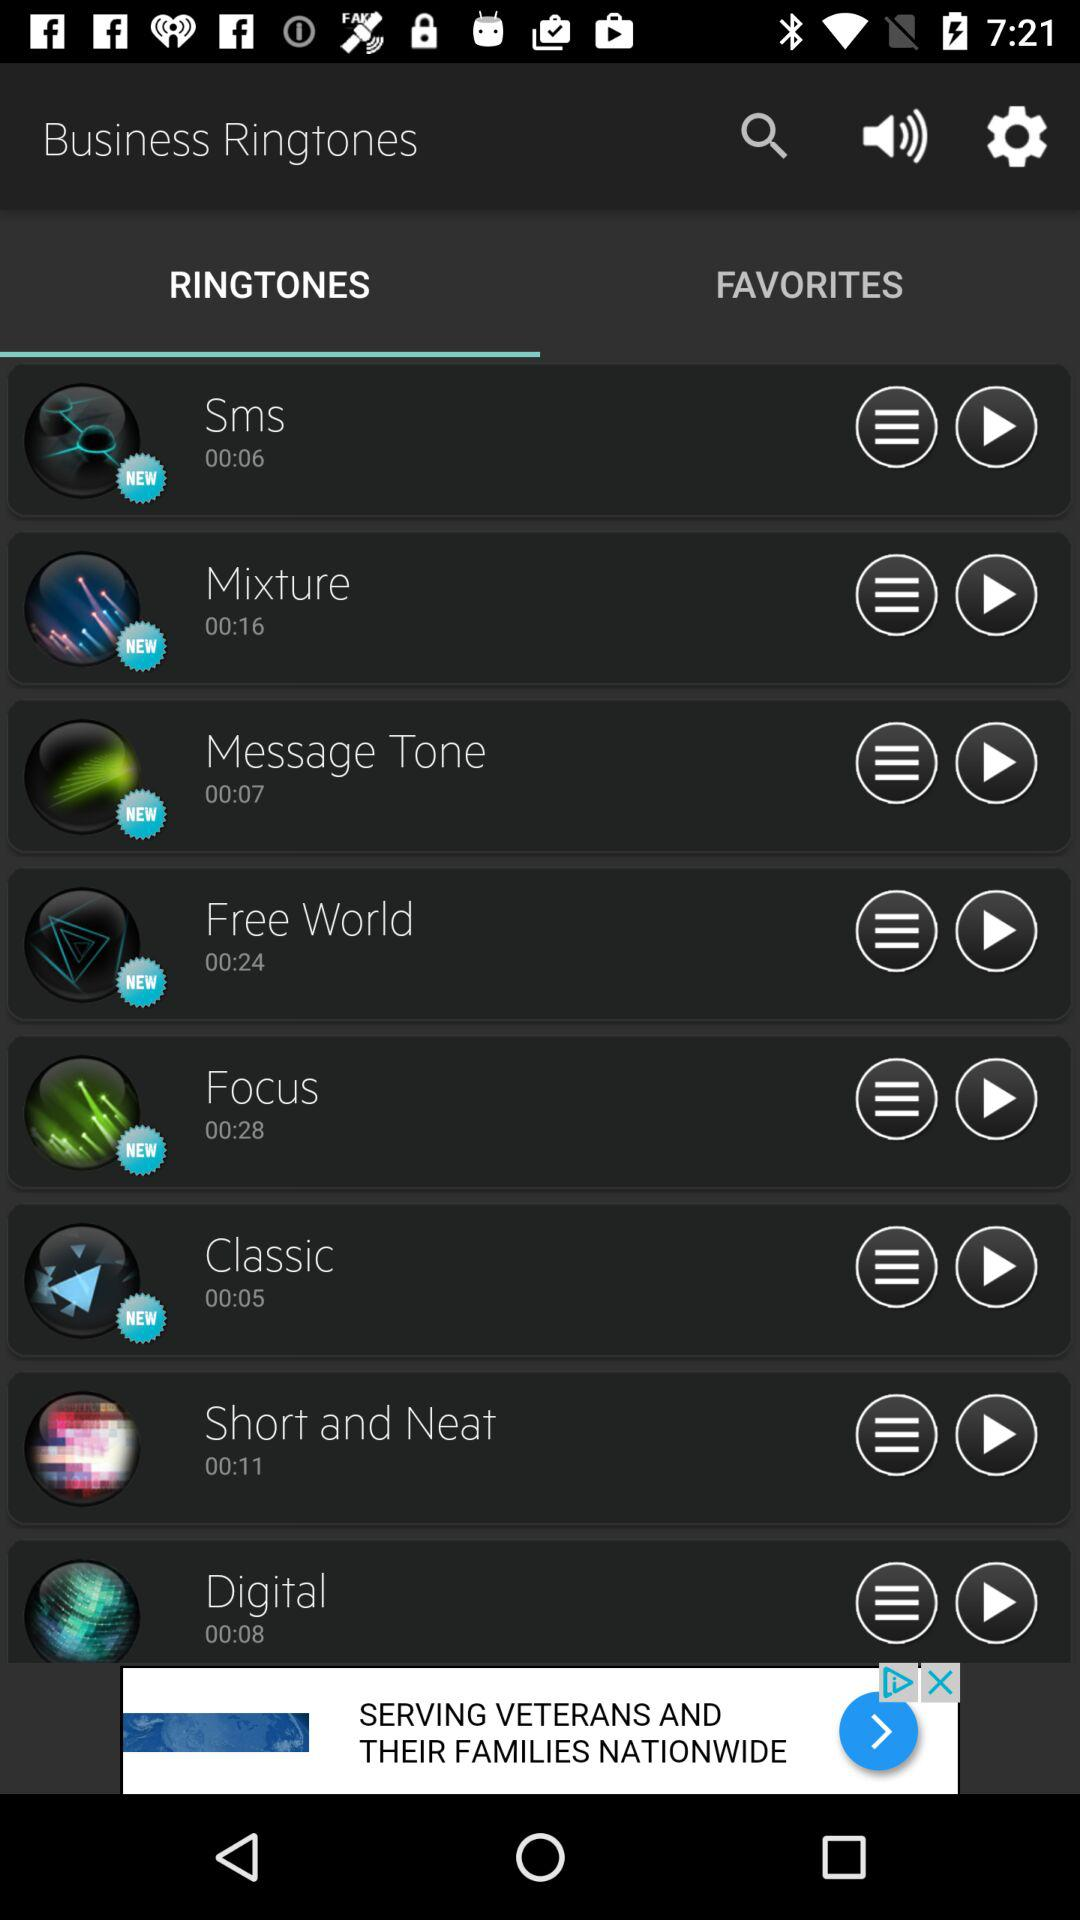What is the duration of the "Classic" ringtone? The duration of the ringtone is 5 seconds. 